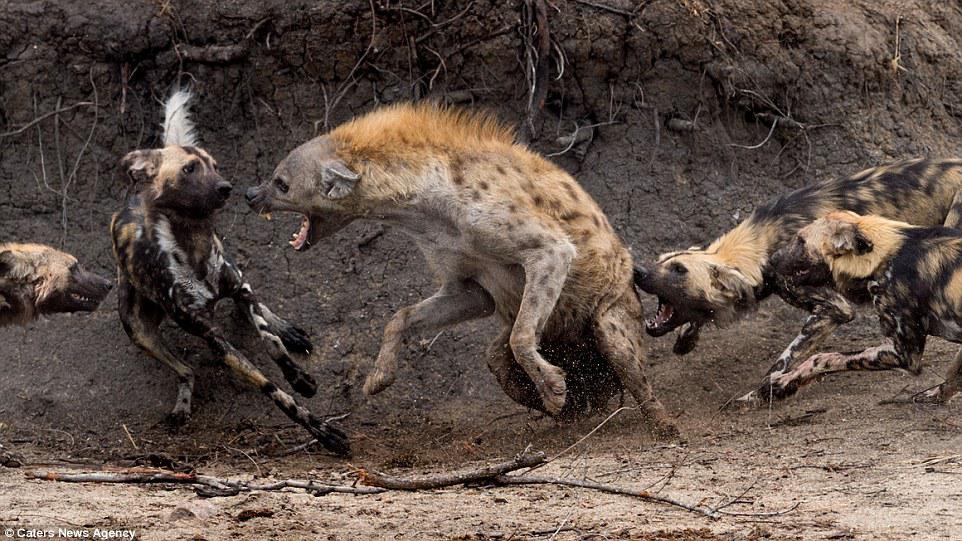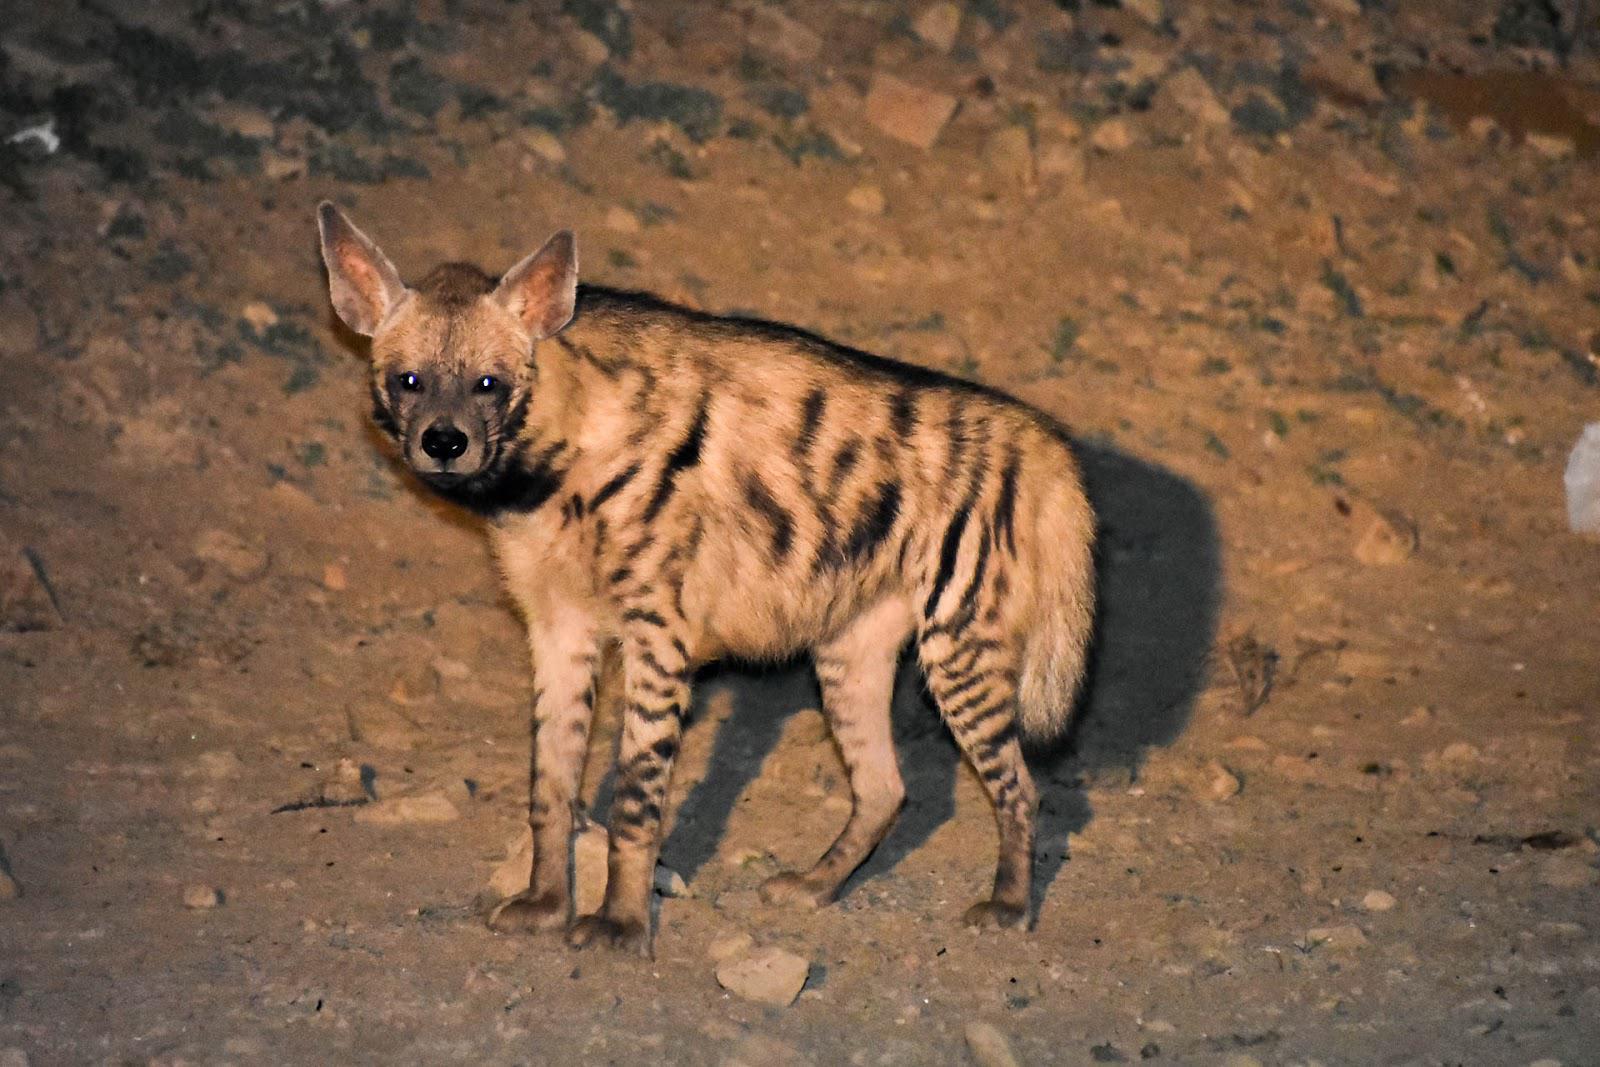The first image is the image on the left, the second image is the image on the right. Examine the images to the left and right. Is the description "An image shows only an upright hyena with erect hair running the length of its body." accurate? Answer yes or no. No. 